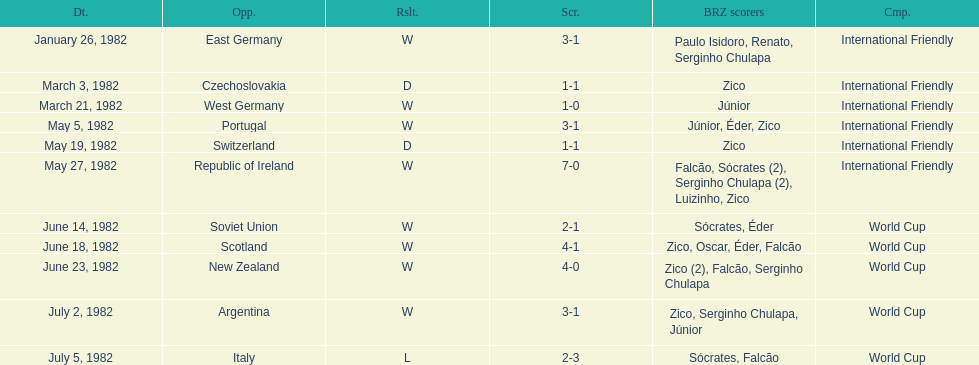How many losses did brazil endure in total? 1. 